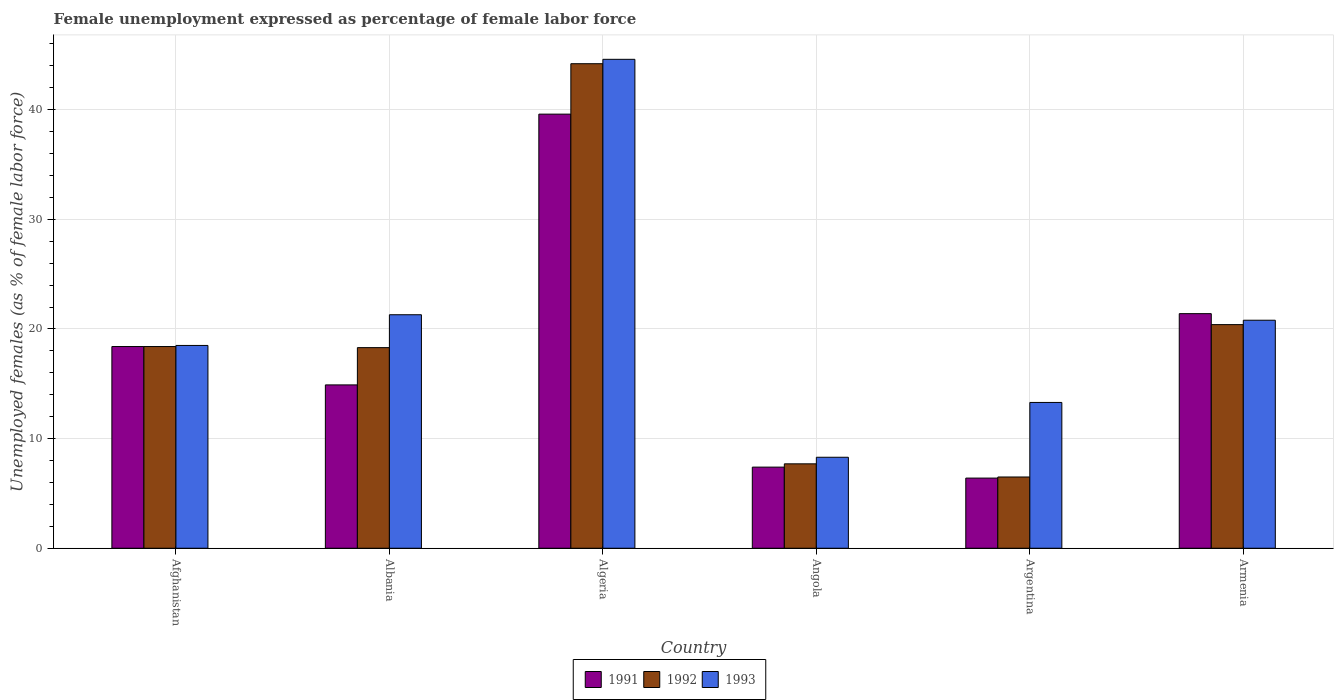How many different coloured bars are there?
Provide a short and direct response. 3. Are the number of bars on each tick of the X-axis equal?
Ensure brevity in your answer.  Yes. What is the label of the 6th group of bars from the left?
Offer a terse response. Armenia. What is the unemployment in females in in 1992 in Armenia?
Give a very brief answer. 20.4. Across all countries, what is the maximum unemployment in females in in 1991?
Provide a succinct answer. 39.6. Across all countries, what is the minimum unemployment in females in in 1991?
Keep it short and to the point. 6.4. In which country was the unemployment in females in in 1992 maximum?
Keep it short and to the point. Algeria. In which country was the unemployment in females in in 1993 minimum?
Give a very brief answer. Angola. What is the total unemployment in females in in 1992 in the graph?
Provide a short and direct response. 115.5. What is the difference between the unemployment in females in in 1993 in Afghanistan and that in Angola?
Provide a succinct answer. 10.2. What is the difference between the unemployment in females in in 1991 in Algeria and the unemployment in females in in 1993 in Argentina?
Your response must be concise. 26.3. What is the average unemployment in females in in 1993 per country?
Offer a terse response. 21.13. What is the difference between the unemployment in females in of/in 1993 and unemployment in females in of/in 1991 in Afghanistan?
Offer a very short reply. 0.1. What is the ratio of the unemployment in females in in 1991 in Afghanistan to that in Armenia?
Offer a very short reply. 0.86. Is the unemployment in females in in 1992 in Angola less than that in Argentina?
Your answer should be very brief. No. What is the difference between the highest and the second highest unemployment in females in in 1992?
Offer a terse response. -25.8. What is the difference between the highest and the lowest unemployment in females in in 1993?
Provide a short and direct response. 36.3. In how many countries, is the unemployment in females in in 1992 greater than the average unemployment in females in in 1992 taken over all countries?
Provide a succinct answer. 2. Is the sum of the unemployment in females in in 1991 in Afghanistan and Albania greater than the maximum unemployment in females in in 1992 across all countries?
Your answer should be very brief. No. What does the 2nd bar from the left in Argentina represents?
Ensure brevity in your answer.  1992. What does the 1st bar from the right in Armenia represents?
Ensure brevity in your answer.  1993. Is it the case that in every country, the sum of the unemployment in females in in 1992 and unemployment in females in in 1993 is greater than the unemployment in females in in 1991?
Your answer should be very brief. Yes. How many bars are there?
Keep it short and to the point. 18. Are all the bars in the graph horizontal?
Provide a short and direct response. No. How many countries are there in the graph?
Provide a succinct answer. 6. What is the difference between two consecutive major ticks on the Y-axis?
Ensure brevity in your answer.  10. How many legend labels are there?
Your response must be concise. 3. How are the legend labels stacked?
Offer a terse response. Horizontal. What is the title of the graph?
Your answer should be compact. Female unemployment expressed as percentage of female labor force. What is the label or title of the X-axis?
Your response must be concise. Country. What is the label or title of the Y-axis?
Offer a terse response. Unemployed females (as % of female labor force). What is the Unemployed females (as % of female labor force) of 1991 in Afghanistan?
Provide a succinct answer. 18.4. What is the Unemployed females (as % of female labor force) of 1992 in Afghanistan?
Your answer should be very brief. 18.4. What is the Unemployed females (as % of female labor force) of 1993 in Afghanistan?
Offer a terse response. 18.5. What is the Unemployed females (as % of female labor force) in 1991 in Albania?
Keep it short and to the point. 14.9. What is the Unemployed females (as % of female labor force) of 1992 in Albania?
Provide a succinct answer. 18.3. What is the Unemployed females (as % of female labor force) of 1993 in Albania?
Give a very brief answer. 21.3. What is the Unemployed females (as % of female labor force) of 1991 in Algeria?
Your answer should be very brief. 39.6. What is the Unemployed females (as % of female labor force) of 1992 in Algeria?
Give a very brief answer. 44.2. What is the Unemployed females (as % of female labor force) of 1993 in Algeria?
Your response must be concise. 44.6. What is the Unemployed females (as % of female labor force) in 1991 in Angola?
Your response must be concise. 7.4. What is the Unemployed females (as % of female labor force) of 1992 in Angola?
Ensure brevity in your answer.  7.7. What is the Unemployed females (as % of female labor force) of 1993 in Angola?
Make the answer very short. 8.3. What is the Unemployed females (as % of female labor force) in 1991 in Argentina?
Keep it short and to the point. 6.4. What is the Unemployed females (as % of female labor force) in 1993 in Argentina?
Offer a very short reply. 13.3. What is the Unemployed females (as % of female labor force) of 1991 in Armenia?
Make the answer very short. 21.4. What is the Unemployed females (as % of female labor force) in 1992 in Armenia?
Provide a succinct answer. 20.4. What is the Unemployed females (as % of female labor force) of 1993 in Armenia?
Offer a very short reply. 20.8. Across all countries, what is the maximum Unemployed females (as % of female labor force) in 1991?
Offer a very short reply. 39.6. Across all countries, what is the maximum Unemployed females (as % of female labor force) of 1992?
Ensure brevity in your answer.  44.2. Across all countries, what is the maximum Unemployed females (as % of female labor force) in 1993?
Make the answer very short. 44.6. Across all countries, what is the minimum Unemployed females (as % of female labor force) in 1991?
Make the answer very short. 6.4. Across all countries, what is the minimum Unemployed females (as % of female labor force) in 1993?
Offer a very short reply. 8.3. What is the total Unemployed females (as % of female labor force) in 1991 in the graph?
Offer a terse response. 108.1. What is the total Unemployed females (as % of female labor force) of 1992 in the graph?
Offer a very short reply. 115.5. What is the total Unemployed females (as % of female labor force) in 1993 in the graph?
Make the answer very short. 126.8. What is the difference between the Unemployed females (as % of female labor force) of 1991 in Afghanistan and that in Albania?
Provide a succinct answer. 3.5. What is the difference between the Unemployed females (as % of female labor force) in 1991 in Afghanistan and that in Algeria?
Keep it short and to the point. -21.2. What is the difference between the Unemployed females (as % of female labor force) of 1992 in Afghanistan and that in Algeria?
Provide a succinct answer. -25.8. What is the difference between the Unemployed females (as % of female labor force) of 1993 in Afghanistan and that in Algeria?
Offer a very short reply. -26.1. What is the difference between the Unemployed females (as % of female labor force) of 1991 in Afghanistan and that in Angola?
Make the answer very short. 11. What is the difference between the Unemployed females (as % of female labor force) of 1991 in Afghanistan and that in Argentina?
Offer a terse response. 12. What is the difference between the Unemployed females (as % of female labor force) in 1991 in Afghanistan and that in Armenia?
Keep it short and to the point. -3. What is the difference between the Unemployed females (as % of female labor force) in 1992 in Afghanistan and that in Armenia?
Provide a short and direct response. -2. What is the difference between the Unemployed females (as % of female labor force) in 1991 in Albania and that in Algeria?
Offer a terse response. -24.7. What is the difference between the Unemployed females (as % of female labor force) of 1992 in Albania and that in Algeria?
Keep it short and to the point. -25.9. What is the difference between the Unemployed females (as % of female labor force) of 1993 in Albania and that in Algeria?
Your answer should be compact. -23.3. What is the difference between the Unemployed females (as % of female labor force) in 1991 in Albania and that in Angola?
Ensure brevity in your answer.  7.5. What is the difference between the Unemployed females (as % of female labor force) in 1993 in Albania and that in Angola?
Offer a terse response. 13. What is the difference between the Unemployed females (as % of female labor force) of 1992 in Albania and that in Argentina?
Give a very brief answer. 11.8. What is the difference between the Unemployed females (as % of female labor force) of 1991 in Albania and that in Armenia?
Ensure brevity in your answer.  -6.5. What is the difference between the Unemployed females (as % of female labor force) of 1993 in Albania and that in Armenia?
Your answer should be compact. 0.5. What is the difference between the Unemployed females (as % of female labor force) in 1991 in Algeria and that in Angola?
Provide a succinct answer. 32.2. What is the difference between the Unemployed females (as % of female labor force) of 1992 in Algeria and that in Angola?
Give a very brief answer. 36.5. What is the difference between the Unemployed females (as % of female labor force) of 1993 in Algeria and that in Angola?
Your answer should be compact. 36.3. What is the difference between the Unemployed females (as % of female labor force) in 1991 in Algeria and that in Argentina?
Keep it short and to the point. 33.2. What is the difference between the Unemployed females (as % of female labor force) in 1992 in Algeria and that in Argentina?
Make the answer very short. 37.7. What is the difference between the Unemployed females (as % of female labor force) in 1993 in Algeria and that in Argentina?
Your answer should be very brief. 31.3. What is the difference between the Unemployed females (as % of female labor force) in 1991 in Algeria and that in Armenia?
Your answer should be very brief. 18.2. What is the difference between the Unemployed females (as % of female labor force) in 1992 in Algeria and that in Armenia?
Provide a short and direct response. 23.8. What is the difference between the Unemployed females (as % of female labor force) in 1993 in Algeria and that in Armenia?
Offer a terse response. 23.8. What is the difference between the Unemployed females (as % of female labor force) in 1991 in Angola and that in Argentina?
Provide a succinct answer. 1. What is the difference between the Unemployed females (as % of female labor force) in 1992 in Angola and that in Armenia?
Your answer should be compact. -12.7. What is the difference between the Unemployed females (as % of female labor force) in 1993 in Angola and that in Armenia?
Ensure brevity in your answer.  -12.5. What is the difference between the Unemployed females (as % of female labor force) of 1991 in Afghanistan and the Unemployed females (as % of female labor force) of 1993 in Albania?
Ensure brevity in your answer.  -2.9. What is the difference between the Unemployed females (as % of female labor force) in 1991 in Afghanistan and the Unemployed females (as % of female labor force) in 1992 in Algeria?
Your response must be concise. -25.8. What is the difference between the Unemployed females (as % of female labor force) in 1991 in Afghanistan and the Unemployed females (as % of female labor force) in 1993 in Algeria?
Ensure brevity in your answer.  -26.2. What is the difference between the Unemployed females (as % of female labor force) of 1992 in Afghanistan and the Unemployed females (as % of female labor force) of 1993 in Algeria?
Give a very brief answer. -26.2. What is the difference between the Unemployed females (as % of female labor force) of 1992 in Afghanistan and the Unemployed females (as % of female labor force) of 1993 in Angola?
Ensure brevity in your answer.  10.1. What is the difference between the Unemployed females (as % of female labor force) of 1991 in Afghanistan and the Unemployed females (as % of female labor force) of 1992 in Argentina?
Ensure brevity in your answer.  11.9. What is the difference between the Unemployed females (as % of female labor force) of 1991 in Afghanistan and the Unemployed females (as % of female labor force) of 1993 in Argentina?
Your answer should be compact. 5.1. What is the difference between the Unemployed females (as % of female labor force) in 1992 in Afghanistan and the Unemployed females (as % of female labor force) in 1993 in Argentina?
Make the answer very short. 5.1. What is the difference between the Unemployed females (as % of female labor force) in 1991 in Afghanistan and the Unemployed females (as % of female labor force) in 1993 in Armenia?
Offer a very short reply. -2.4. What is the difference between the Unemployed females (as % of female labor force) in 1991 in Albania and the Unemployed females (as % of female labor force) in 1992 in Algeria?
Give a very brief answer. -29.3. What is the difference between the Unemployed females (as % of female labor force) of 1991 in Albania and the Unemployed females (as % of female labor force) of 1993 in Algeria?
Offer a terse response. -29.7. What is the difference between the Unemployed females (as % of female labor force) of 1992 in Albania and the Unemployed females (as % of female labor force) of 1993 in Algeria?
Offer a terse response. -26.3. What is the difference between the Unemployed females (as % of female labor force) of 1991 in Albania and the Unemployed females (as % of female labor force) of 1993 in Angola?
Offer a terse response. 6.6. What is the difference between the Unemployed females (as % of female labor force) of 1991 in Albania and the Unemployed females (as % of female labor force) of 1992 in Argentina?
Your response must be concise. 8.4. What is the difference between the Unemployed females (as % of female labor force) of 1992 in Albania and the Unemployed females (as % of female labor force) of 1993 in Argentina?
Offer a terse response. 5. What is the difference between the Unemployed females (as % of female labor force) of 1991 in Albania and the Unemployed females (as % of female labor force) of 1992 in Armenia?
Your response must be concise. -5.5. What is the difference between the Unemployed females (as % of female labor force) of 1991 in Albania and the Unemployed females (as % of female labor force) of 1993 in Armenia?
Your answer should be very brief. -5.9. What is the difference between the Unemployed females (as % of female labor force) of 1992 in Albania and the Unemployed females (as % of female labor force) of 1993 in Armenia?
Offer a very short reply. -2.5. What is the difference between the Unemployed females (as % of female labor force) in 1991 in Algeria and the Unemployed females (as % of female labor force) in 1992 in Angola?
Offer a terse response. 31.9. What is the difference between the Unemployed females (as % of female labor force) in 1991 in Algeria and the Unemployed females (as % of female labor force) in 1993 in Angola?
Provide a short and direct response. 31.3. What is the difference between the Unemployed females (as % of female labor force) of 1992 in Algeria and the Unemployed females (as % of female labor force) of 1993 in Angola?
Keep it short and to the point. 35.9. What is the difference between the Unemployed females (as % of female labor force) of 1991 in Algeria and the Unemployed females (as % of female labor force) of 1992 in Argentina?
Give a very brief answer. 33.1. What is the difference between the Unemployed females (as % of female labor force) in 1991 in Algeria and the Unemployed females (as % of female labor force) in 1993 in Argentina?
Offer a very short reply. 26.3. What is the difference between the Unemployed females (as % of female labor force) of 1992 in Algeria and the Unemployed females (as % of female labor force) of 1993 in Argentina?
Provide a short and direct response. 30.9. What is the difference between the Unemployed females (as % of female labor force) in 1991 in Algeria and the Unemployed females (as % of female labor force) in 1992 in Armenia?
Offer a terse response. 19.2. What is the difference between the Unemployed females (as % of female labor force) in 1991 in Algeria and the Unemployed females (as % of female labor force) in 1993 in Armenia?
Your answer should be very brief. 18.8. What is the difference between the Unemployed females (as % of female labor force) in 1992 in Algeria and the Unemployed females (as % of female labor force) in 1993 in Armenia?
Ensure brevity in your answer.  23.4. What is the difference between the Unemployed females (as % of female labor force) in 1991 in Angola and the Unemployed females (as % of female labor force) in 1992 in Armenia?
Make the answer very short. -13. What is the difference between the Unemployed females (as % of female labor force) in 1991 in Angola and the Unemployed females (as % of female labor force) in 1993 in Armenia?
Make the answer very short. -13.4. What is the difference between the Unemployed females (as % of female labor force) of 1992 in Angola and the Unemployed females (as % of female labor force) of 1993 in Armenia?
Keep it short and to the point. -13.1. What is the difference between the Unemployed females (as % of female labor force) of 1991 in Argentina and the Unemployed females (as % of female labor force) of 1993 in Armenia?
Provide a short and direct response. -14.4. What is the difference between the Unemployed females (as % of female labor force) in 1992 in Argentina and the Unemployed females (as % of female labor force) in 1993 in Armenia?
Ensure brevity in your answer.  -14.3. What is the average Unemployed females (as % of female labor force) in 1991 per country?
Ensure brevity in your answer.  18.02. What is the average Unemployed females (as % of female labor force) of 1992 per country?
Offer a very short reply. 19.25. What is the average Unemployed females (as % of female labor force) in 1993 per country?
Make the answer very short. 21.13. What is the difference between the Unemployed females (as % of female labor force) of 1992 and Unemployed females (as % of female labor force) of 1993 in Afghanistan?
Give a very brief answer. -0.1. What is the difference between the Unemployed females (as % of female labor force) in 1991 and Unemployed females (as % of female labor force) in 1993 in Albania?
Your answer should be compact. -6.4. What is the difference between the Unemployed females (as % of female labor force) of 1992 and Unemployed females (as % of female labor force) of 1993 in Albania?
Your answer should be very brief. -3. What is the difference between the Unemployed females (as % of female labor force) in 1991 and Unemployed females (as % of female labor force) in 1993 in Algeria?
Ensure brevity in your answer.  -5. What is the difference between the Unemployed females (as % of female labor force) of 1992 and Unemployed females (as % of female labor force) of 1993 in Algeria?
Make the answer very short. -0.4. What is the difference between the Unemployed females (as % of female labor force) in 1991 and Unemployed females (as % of female labor force) in 1993 in Argentina?
Your answer should be compact. -6.9. What is the ratio of the Unemployed females (as % of female labor force) of 1991 in Afghanistan to that in Albania?
Provide a succinct answer. 1.23. What is the ratio of the Unemployed females (as % of female labor force) of 1992 in Afghanistan to that in Albania?
Provide a succinct answer. 1.01. What is the ratio of the Unemployed females (as % of female labor force) in 1993 in Afghanistan to that in Albania?
Your response must be concise. 0.87. What is the ratio of the Unemployed females (as % of female labor force) in 1991 in Afghanistan to that in Algeria?
Offer a terse response. 0.46. What is the ratio of the Unemployed females (as % of female labor force) in 1992 in Afghanistan to that in Algeria?
Offer a very short reply. 0.42. What is the ratio of the Unemployed females (as % of female labor force) in 1993 in Afghanistan to that in Algeria?
Offer a very short reply. 0.41. What is the ratio of the Unemployed females (as % of female labor force) of 1991 in Afghanistan to that in Angola?
Keep it short and to the point. 2.49. What is the ratio of the Unemployed females (as % of female labor force) in 1992 in Afghanistan to that in Angola?
Provide a short and direct response. 2.39. What is the ratio of the Unemployed females (as % of female labor force) of 1993 in Afghanistan to that in Angola?
Your answer should be very brief. 2.23. What is the ratio of the Unemployed females (as % of female labor force) of 1991 in Afghanistan to that in Argentina?
Keep it short and to the point. 2.88. What is the ratio of the Unemployed females (as % of female labor force) in 1992 in Afghanistan to that in Argentina?
Keep it short and to the point. 2.83. What is the ratio of the Unemployed females (as % of female labor force) of 1993 in Afghanistan to that in Argentina?
Your answer should be compact. 1.39. What is the ratio of the Unemployed females (as % of female labor force) in 1991 in Afghanistan to that in Armenia?
Give a very brief answer. 0.86. What is the ratio of the Unemployed females (as % of female labor force) in 1992 in Afghanistan to that in Armenia?
Keep it short and to the point. 0.9. What is the ratio of the Unemployed females (as % of female labor force) in 1993 in Afghanistan to that in Armenia?
Ensure brevity in your answer.  0.89. What is the ratio of the Unemployed females (as % of female labor force) of 1991 in Albania to that in Algeria?
Provide a succinct answer. 0.38. What is the ratio of the Unemployed females (as % of female labor force) of 1992 in Albania to that in Algeria?
Your answer should be very brief. 0.41. What is the ratio of the Unemployed females (as % of female labor force) of 1993 in Albania to that in Algeria?
Your answer should be compact. 0.48. What is the ratio of the Unemployed females (as % of female labor force) of 1991 in Albania to that in Angola?
Offer a very short reply. 2.01. What is the ratio of the Unemployed females (as % of female labor force) in 1992 in Albania to that in Angola?
Your answer should be very brief. 2.38. What is the ratio of the Unemployed females (as % of female labor force) of 1993 in Albania to that in Angola?
Provide a short and direct response. 2.57. What is the ratio of the Unemployed females (as % of female labor force) of 1991 in Albania to that in Argentina?
Give a very brief answer. 2.33. What is the ratio of the Unemployed females (as % of female labor force) of 1992 in Albania to that in Argentina?
Make the answer very short. 2.82. What is the ratio of the Unemployed females (as % of female labor force) of 1993 in Albania to that in Argentina?
Your answer should be compact. 1.6. What is the ratio of the Unemployed females (as % of female labor force) in 1991 in Albania to that in Armenia?
Provide a succinct answer. 0.7. What is the ratio of the Unemployed females (as % of female labor force) of 1992 in Albania to that in Armenia?
Provide a short and direct response. 0.9. What is the ratio of the Unemployed females (as % of female labor force) in 1991 in Algeria to that in Angola?
Provide a succinct answer. 5.35. What is the ratio of the Unemployed females (as % of female labor force) in 1992 in Algeria to that in Angola?
Your answer should be compact. 5.74. What is the ratio of the Unemployed females (as % of female labor force) in 1993 in Algeria to that in Angola?
Provide a short and direct response. 5.37. What is the ratio of the Unemployed females (as % of female labor force) in 1991 in Algeria to that in Argentina?
Provide a short and direct response. 6.19. What is the ratio of the Unemployed females (as % of female labor force) in 1993 in Algeria to that in Argentina?
Ensure brevity in your answer.  3.35. What is the ratio of the Unemployed females (as % of female labor force) in 1991 in Algeria to that in Armenia?
Offer a very short reply. 1.85. What is the ratio of the Unemployed females (as % of female labor force) in 1992 in Algeria to that in Armenia?
Your answer should be compact. 2.17. What is the ratio of the Unemployed females (as % of female labor force) of 1993 in Algeria to that in Armenia?
Your response must be concise. 2.14. What is the ratio of the Unemployed females (as % of female labor force) in 1991 in Angola to that in Argentina?
Offer a very short reply. 1.16. What is the ratio of the Unemployed females (as % of female labor force) of 1992 in Angola to that in Argentina?
Offer a very short reply. 1.18. What is the ratio of the Unemployed females (as % of female labor force) of 1993 in Angola to that in Argentina?
Ensure brevity in your answer.  0.62. What is the ratio of the Unemployed females (as % of female labor force) of 1991 in Angola to that in Armenia?
Keep it short and to the point. 0.35. What is the ratio of the Unemployed females (as % of female labor force) of 1992 in Angola to that in Armenia?
Your answer should be compact. 0.38. What is the ratio of the Unemployed females (as % of female labor force) in 1993 in Angola to that in Armenia?
Offer a very short reply. 0.4. What is the ratio of the Unemployed females (as % of female labor force) of 1991 in Argentina to that in Armenia?
Make the answer very short. 0.3. What is the ratio of the Unemployed females (as % of female labor force) in 1992 in Argentina to that in Armenia?
Provide a short and direct response. 0.32. What is the ratio of the Unemployed females (as % of female labor force) of 1993 in Argentina to that in Armenia?
Provide a succinct answer. 0.64. What is the difference between the highest and the second highest Unemployed females (as % of female labor force) in 1992?
Make the answer very short. 23.8. What is the difference between the highest and the second highest Unemployed females (as % of female labor force) of 1993?
Provide a succinct answer. 23.3. What is the difference between the highest and the lowest Unemployed females (as % of female labor force) of 1991?
Offer a terse response. 33.2. What is the difference between the highest and the lowest Unemployed females (as % of female labor force) of 1992?
Your response must be concise. 37.7. What is the difference between the highest and the lowest Unemployed females (as % of female labor force) in 1993?
Your answer should be compact. 36.3. 